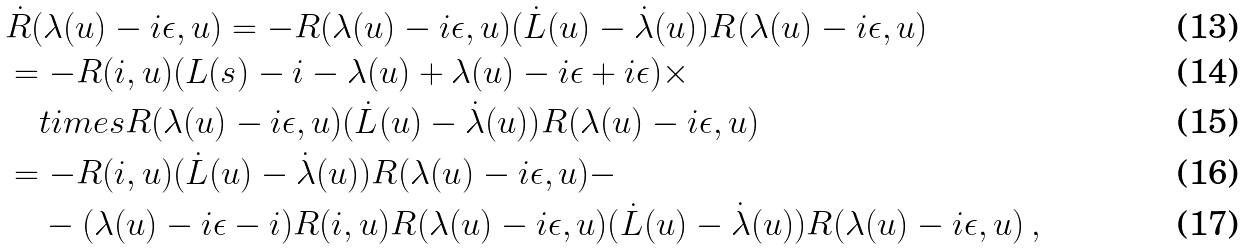<formula> <loc_0><loc_0><loc_500><loc_500>& \dot { R } ( \lambda ( u ) - i \epsilon , u ) = - R ( \lambda ( u ) - i \epsilon , u ) ( \dot { L } ( u ) - \dot { \lambda } ( u ) ) R ( \lambda ( u ) - i \epsilon , u ) \\ & = - R ( i , u ) ( L ( s ) - i - \lambda ( u ) + \lambda ( u ) - i \epsilon + i \epsilon ) \times \\ & \quad t i m e s R ( \lambda ( u ) - i \epsilon , u ) ( \dot { L } ( u ) - \dot { \lambda } ( u ) ) R ( \lambda ( u ) - i \epsilon , u ) \\ & = - R ( i , u ) ( \dot { L } ( u ) - \dot { \lambda } ( u ) ) R ( \lambda ( u ) - i \epsilon , u ) - \\ & \quad - ( \lambda ( u ) - i \epsilon - i ) R ( i , u ) R ( \lambda ( u ) - i \epsilon , u ) ( \dot { L } ( u ) - \dot { \lambda } ( u ) ) R ( \lambda ( u ) - i \epsilon , u ) \, ,</formula> 